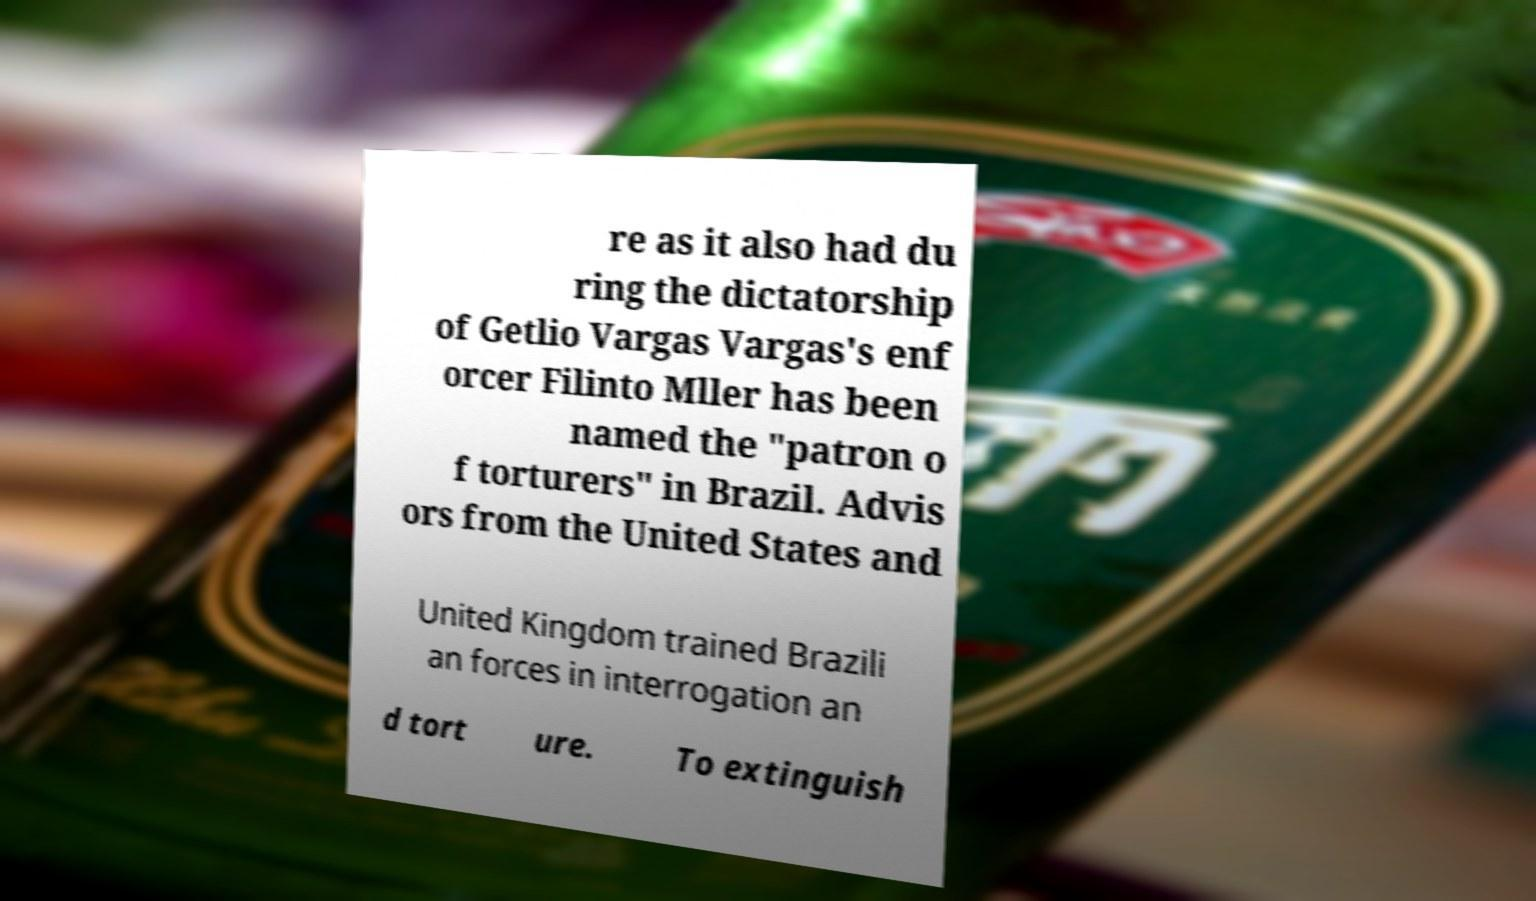Please identify and transcribe the text found in this image. re as it also had du ring the dictatorship of Getlio Vargas Vargas's enf orcer Filinto Mller has been named the "patron o f torturers" in Brazil. Advis ors from the United States and United Kingdom trained Brazili an forces in interrogation an d tort ure. To extinguish 